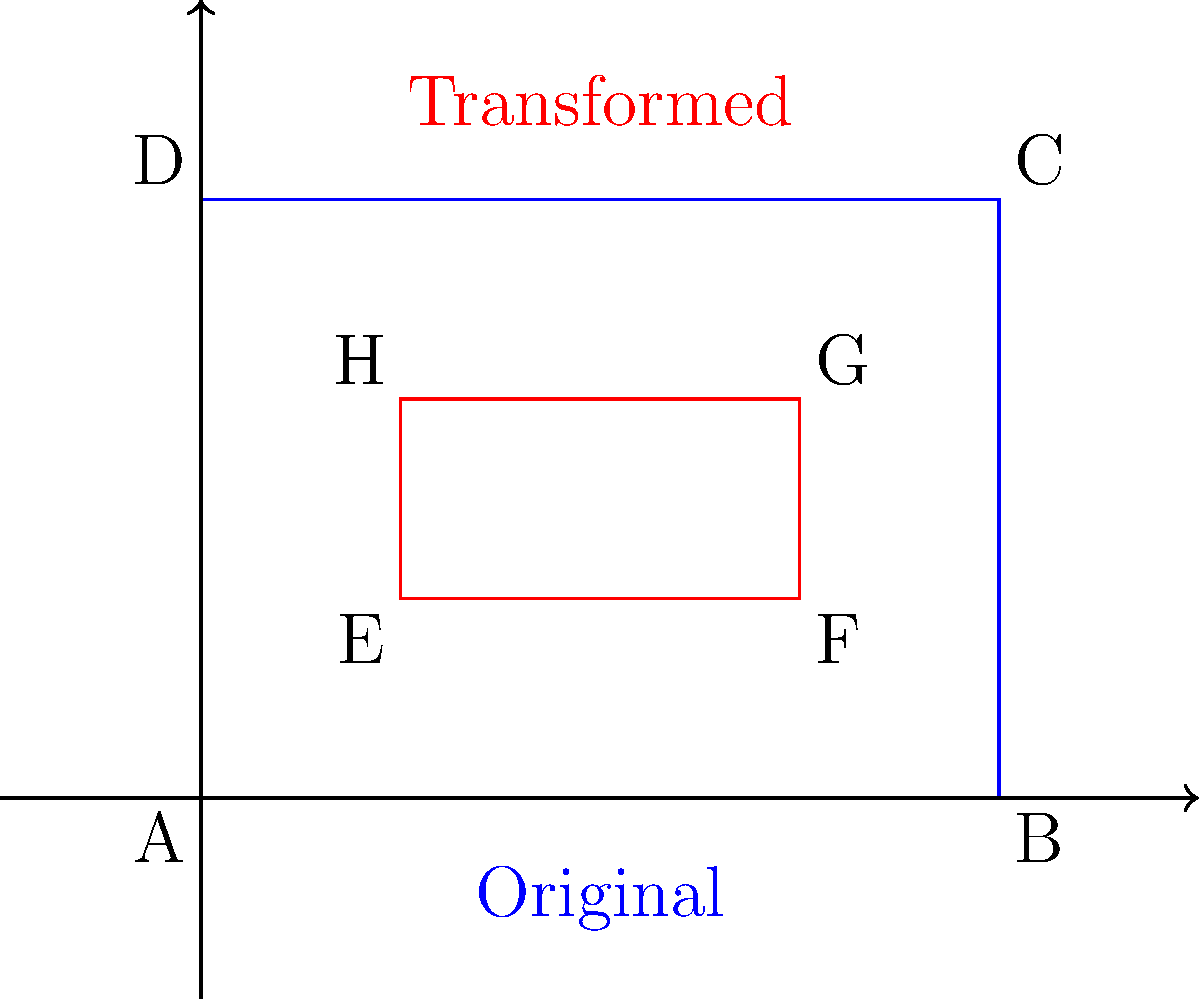Your property manager has proposed a redesign of your beachfront garden. The current rectangular garden (ABCD) measures 40 feet by 30 feet. The new design (EFGH) involves a series of transformations: first, a 50% reduction in size, then a 90-degree clockwise rotation, followed by a translation 10 feet right and 10 feet up from the original garden's bottom-left corner. What is the area of the new garden design in square feet? Let's approach this step-by-step:

1) Original garden dimensions:
   Length (AB) = 40 feet
   Width (AD) = 30 feet
   Area = 40 * 30 = 1200 sq ft

2) 50% reduction in size:
   New length = 40 * 0.5 = 20 feet
   New width = 30 * 0.5 = 15 feet
   New area = 20 * 15 = 300 sq ft

3) 90-degree clockwise rotation:
   This changes the orientation but not the area.
   After rotation: length = 15 feet, width = 20 feet
   Area remains 300 sq ft

4) Translation:
   Moving the garden doesn't change its size or area.
   Area still remains 300 sq ft

Therefore, the area of the new garden design is 300 square feet.
Answer: 300 sq ft 